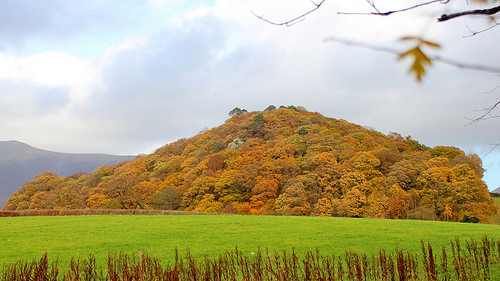<image>
Can you confirm if the plant is above the grass? No. The plant is not positioned above the grass. The vertical arrangement shows a different relationship. 